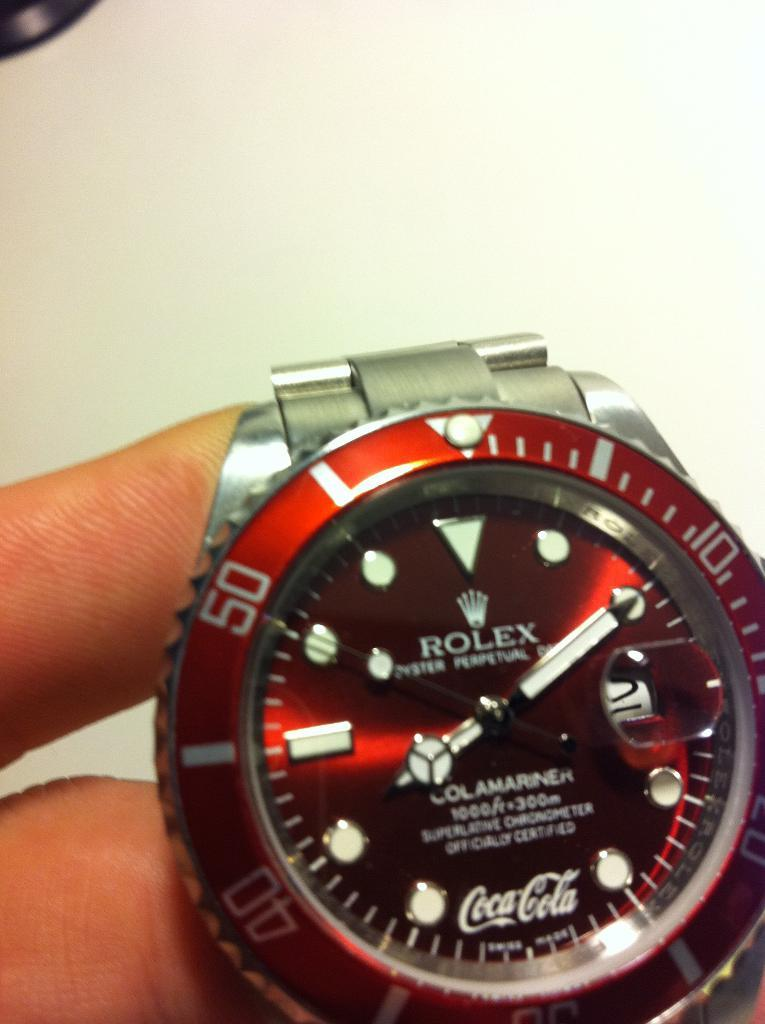<image>
Present a compact description of the photo's key features. Rolex watch that says the time 8:10 and has a Coca Cola sponsor on the watch face. 